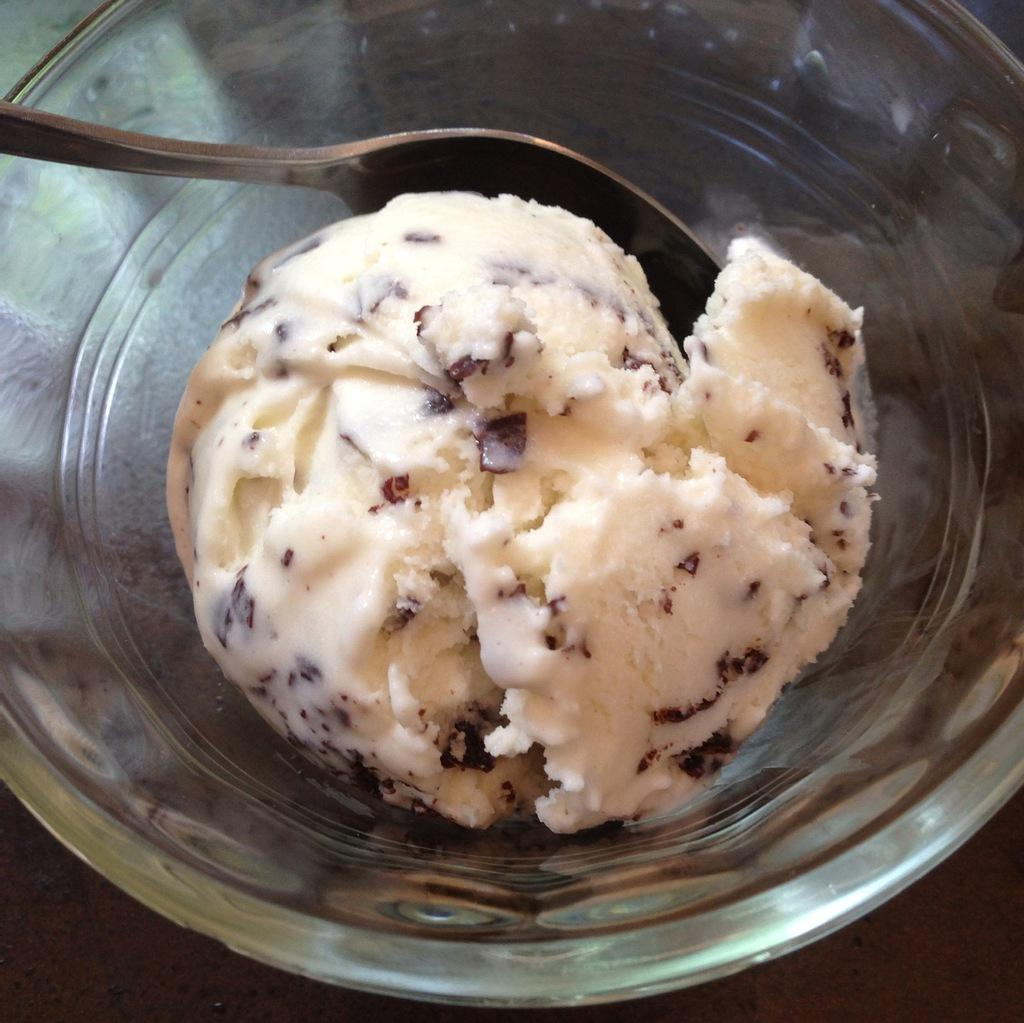What is the main subject of the image? The main subject of the image is an ice cream. What object is present in the image that could be used to eat the ice cream? There is a spoon in the image. Where is the spoon located in relation to the ice cream? The spoon is in a glass bowl. What type of coach is visible in the image? There is no coach present in the image. What industry is represented by the ice cream in the image? The image does not represent any specific industry; it simply shows an ice cream and a spoon in a glass bowl. 